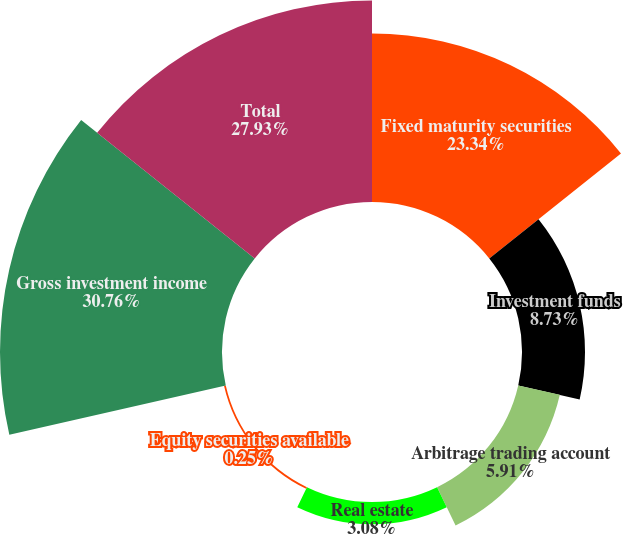Convert chart. <chart><loc_0><loc_0><loc_500><loc_500><pie_chart><fcel>Fixed maturity securities<fcel>Investment funds<fcel>Arbitrage trading account<fcel>Real estate<fcel>Equity securities available<fcel>Gross investment income<fcel>Total<nl><fcel>23.34%<fcel>8.73%<fcel>5.91%<fcel>3.08%<fcel>0.25%<fcel>30.76%<fcel>27.93%<nl></chart> 